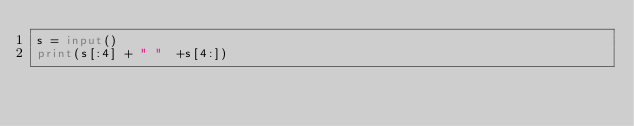<code> <loc_0><loc_0><loc_500><loc_500><_Python_>s = input()
print(s[:4] + " "  +s[4:])</code> 